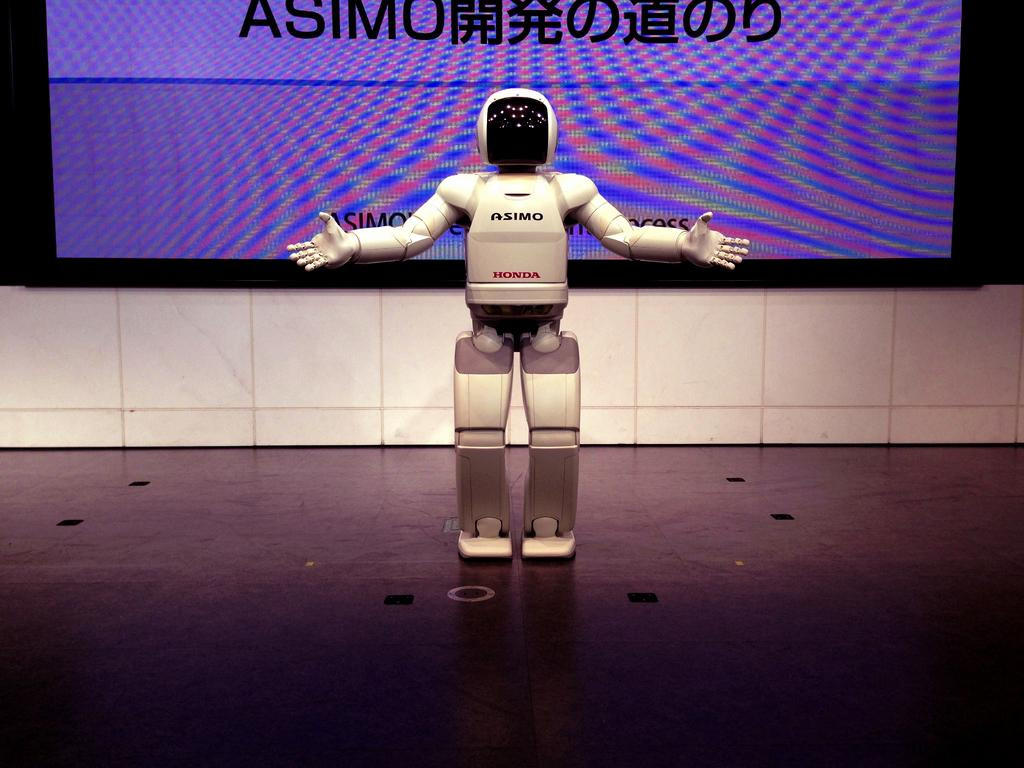What is the main subject of the image? There is a robot in the image. Can you describe the background of the image? There is a screen in the background of the image. What type of muscle can be seen on the robot in the image? There are no muscles present on the robot in the image, as it is a mechanical object. 